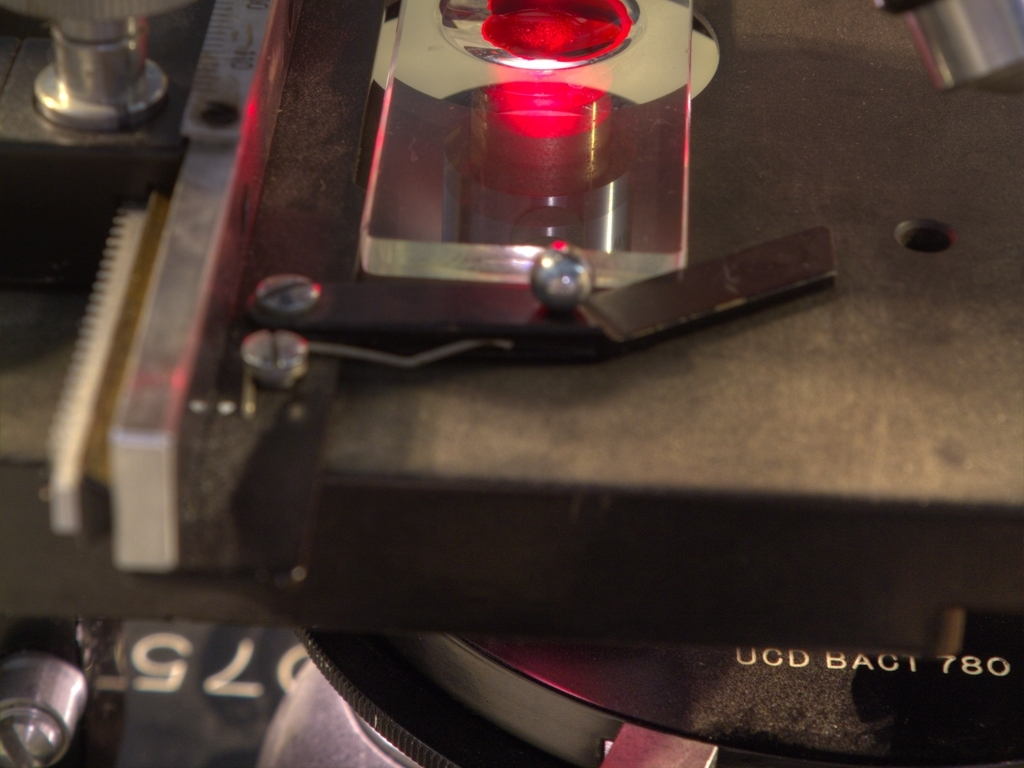Are there excessive details in the image? The image displays a close-up view of a scientific or precision instrument, likely used in a laboratory or research setting, with components such as gears, calibration markings, and a laser. While there is a considerable amount of detail, 'excessive' may be subjective as the details seem relevant to the instrument's function. 